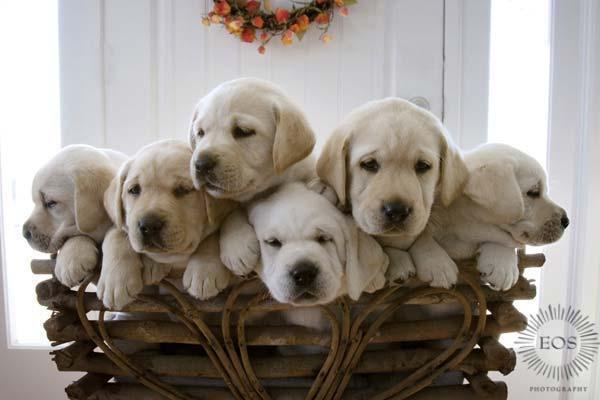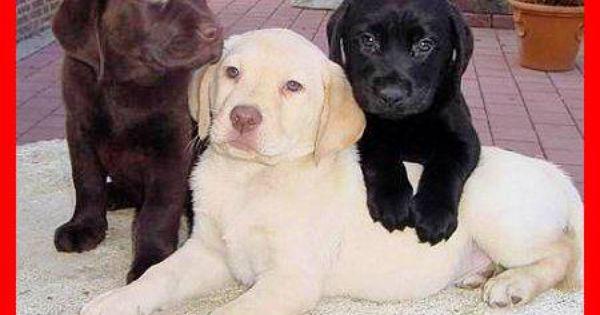The first image is the image on the left, the second image is the image on the right. Assess this claim about the two images: "There are no more than five dogs". Correct or not? Answer yes or no. No. 